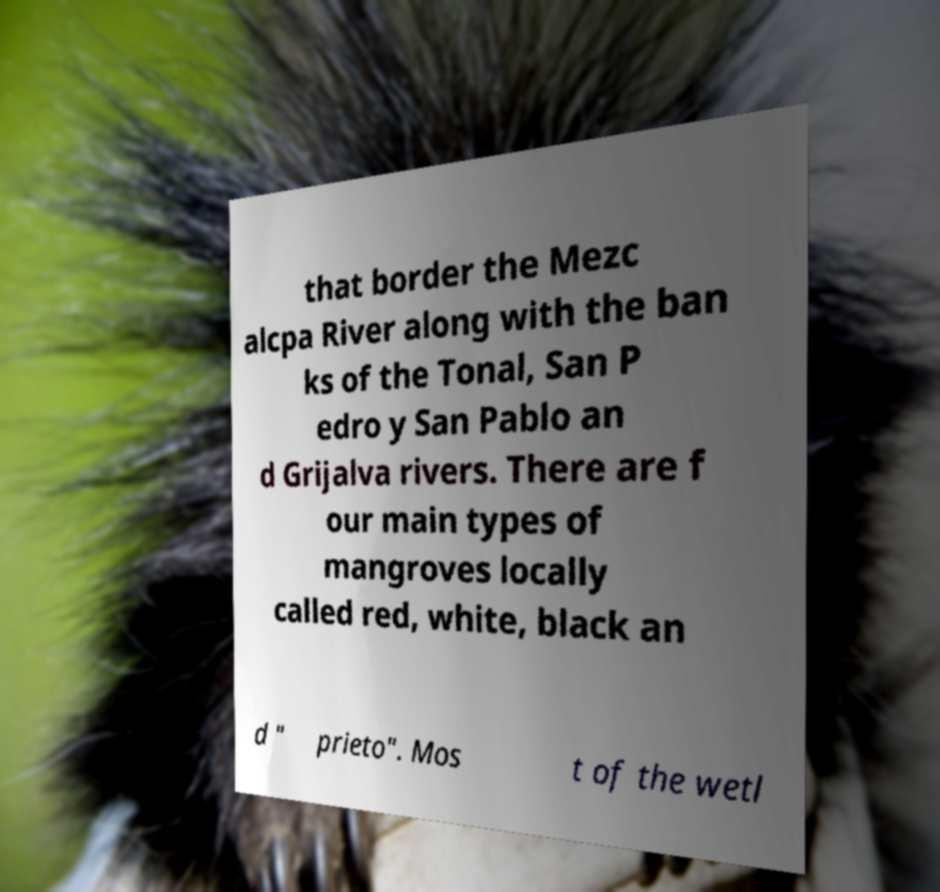Could you extract and type out the text from this image? that border the Mezc alcpa River along with the ban ks of the Tonal, San P edro y San Pablo an d Grijalva rivers. There are f our main types of mangroves locally called red, white, black an d " prieto". Mos t of the wetl 